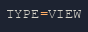<code> <loc_0><loc_0><loc_500><loc_500><_VisualBasic_>TYPE=VIEW</code> 